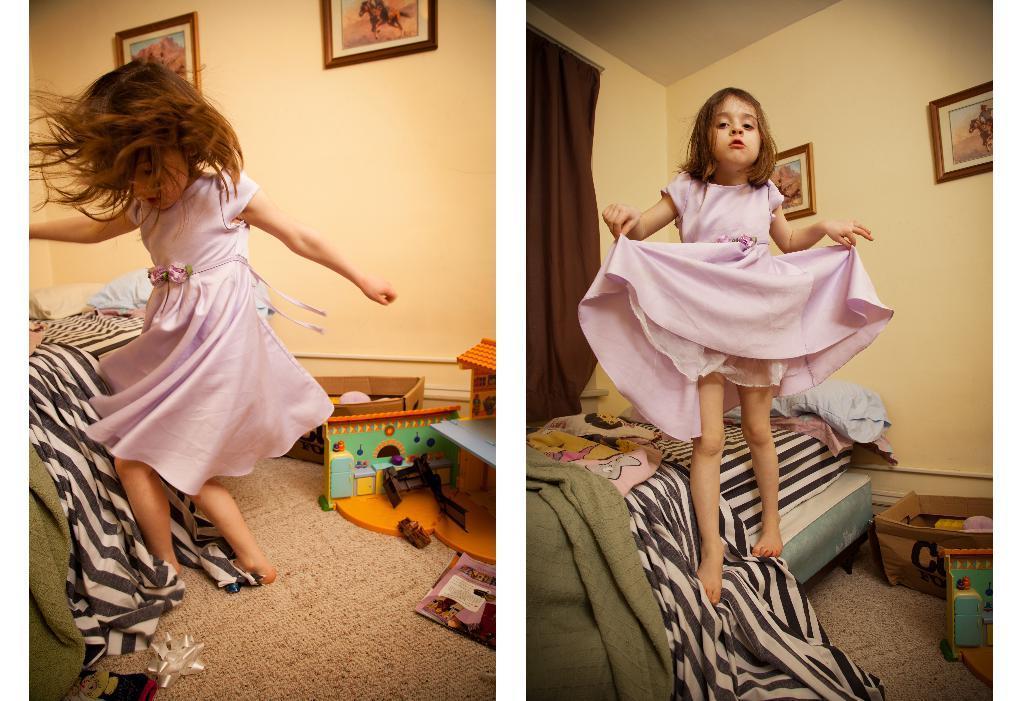Please provide a concise description of this image. This is a collage image of two pictures on which we can see there is a girl playing and standing on the bed beside her there are some toys on carpet and photos on the wall. 